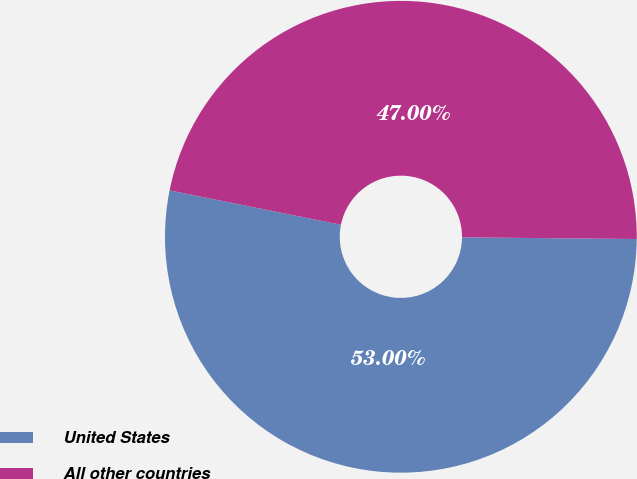Convert chart to OTSL. <chart><loc_0><loc_0><loc_500><loc_500><pie_chart><fcel>United States<fcel>All other countries<nl><fcel>53.0%<fcel>47.0%<nl></chart> 